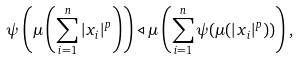Convert formula to latex. <formula><loc_0><loc_0><loc_500><loc_500>\psi \left ( \mu \left ( \sum _ { i = 1 } ^ { n } | x _ { i } | ^ { p } \right ) \right ) \triangleleft \mu \left ( \sum _ { i = 1 } ^ { n } \psi ( \mu ( | x _ { i } | ^ { p } ) ) \right ) ,</formula> 